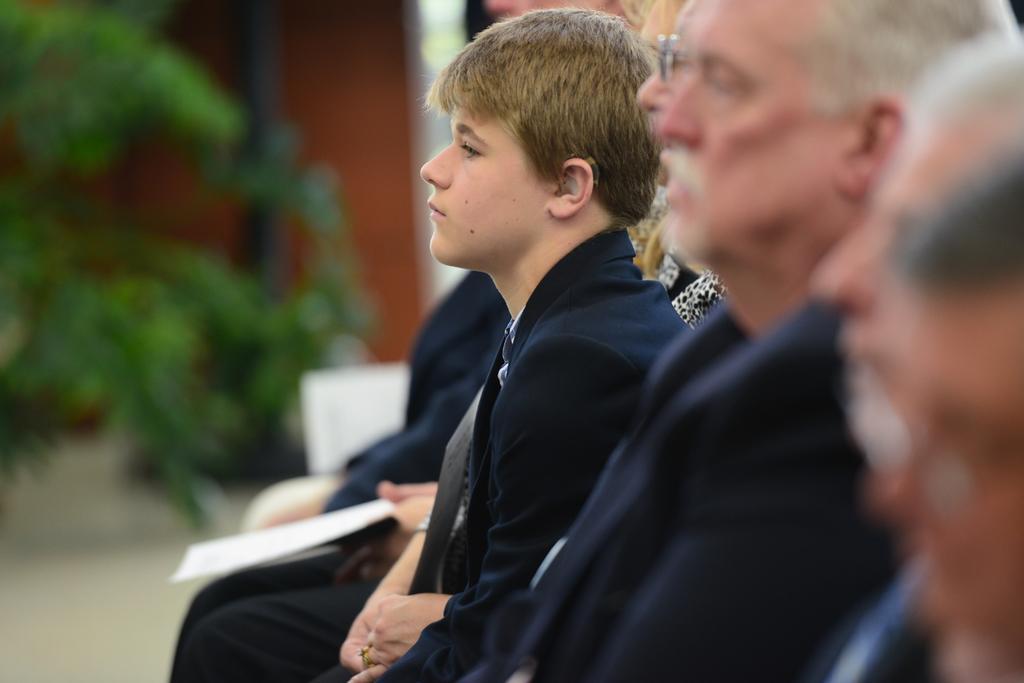Could you give a brief overview of what you see in this image? In this picture I can observe some people in the middle of the picture. The background is blurred. 